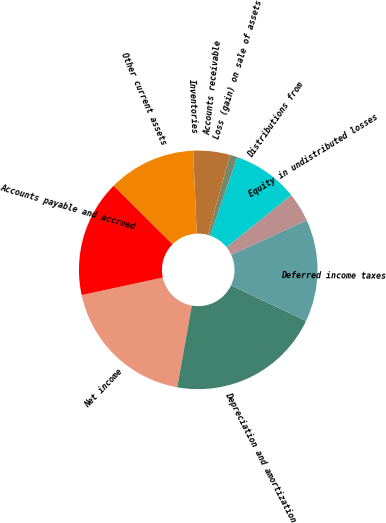<chart> <loc_0><loc_0><loc_500><loc_500><pie_chart><fcel>Net income<fcel>Depreciation and amortization<fcel>Deferred income taxes<fcel>Equity in undistributed losses<fcel>Distributions from<fcel>Loss (gain) on sale of assets<fcel>Accounts receivable<fcel>Inventories<fcel>Other current assets<fcel>Accounts payable and accrued<nl><fcel>18.8%<fcel>20.78%<fcel>13.86%<fcel>3.97%<fcel>8.91%<fcel>1.0%<fcel>4.96%<fcel>0.01%<fcel>11.88%<fcel>15.83%<nl></chart> 